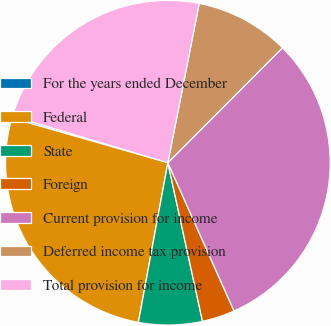<chart> <loc_0><loc_0><loc_500><loc_500><pie_chart><fcel>For the years ended December<fcel>Federal<fcel>State<fcel>Foreign<fcel>Current provision for income<fcel>Deferred income tax provision<fcel>Total provision for income<nl><fcel>0.2%<fcel>26.53%<fcel>6.33%<fcel>3.26%<fcel>30.84%<fcel>9.39%<fcel>23.46%<nl></chart> 